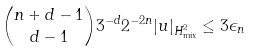<formula> <loc_0><loc_0><loc_500><loc_500>\binom { n + d - 1 } { d - 1 } 3 ^ { - d } 2 ^ { - 2 n } | u | _ { H ^ { 2 } _ { \text {mix} } } \leq 3 \epsilon _ { n }</formula> 